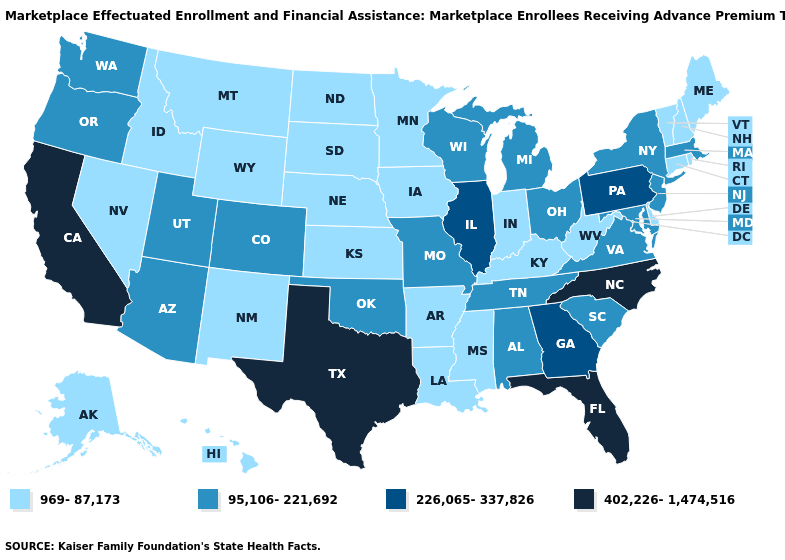Among the states that border Texas , which have the lowest value?
Be succinct. Arkansas, Louisiana, New Mexico. What is the lowest value in states that border West Virginia?
Quick response, please. 969-87,173. What is the lowest value in the West?
Write a very short answer. 969-87,173. Name the states that have a value in the range 95,106-221,692?
Concise answer only. Alabama, Arizona, Colorado, Maryland, Massachusetts, Michigan, Missouri, New Jersey, New York, Ohio, Oklahoma, Oregon, South Carolina, Tennessee, Utah, Virginia, Washington, Wisconsin. Name the states that have a value in the range 226,065-337,826?
Concise answer only. Georgia, Illinois, Pennsylvania. Does Illinois have the lowest value in the MidWest?
Concise answer only. No. What is the value of West Virginia?
Answer briefly. 969-87,173. Name the states that have a value in the range 95,106-221,692?
Short answer required. Alabama, Arizona, Colorado, Maryland, Massachusetts, Michigan, Missouri, New Jersey, New York, Ohio, Oklahoma, Oregon, South Carolina, Tennessee, Utah, Virginia, Washington, Wisconsin. Does the first symbol in the legend represent the smallest category?
Quick response, please. Yes. What is the highest value in the Northeast ?
Answer briefly. 226,065-337,826. What is the value of North Carolina?
Short answer required. 402,226-1,474,516. Does North Carolina have the highest value in the USA?
Short answer required. Yes. Does Illinois have a higher value than Arizona?
Give a very brief answer. Yes. 